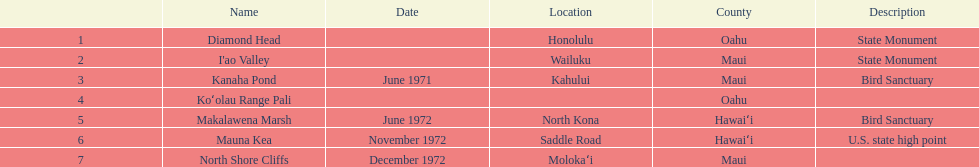How many names lack a description? 2. 